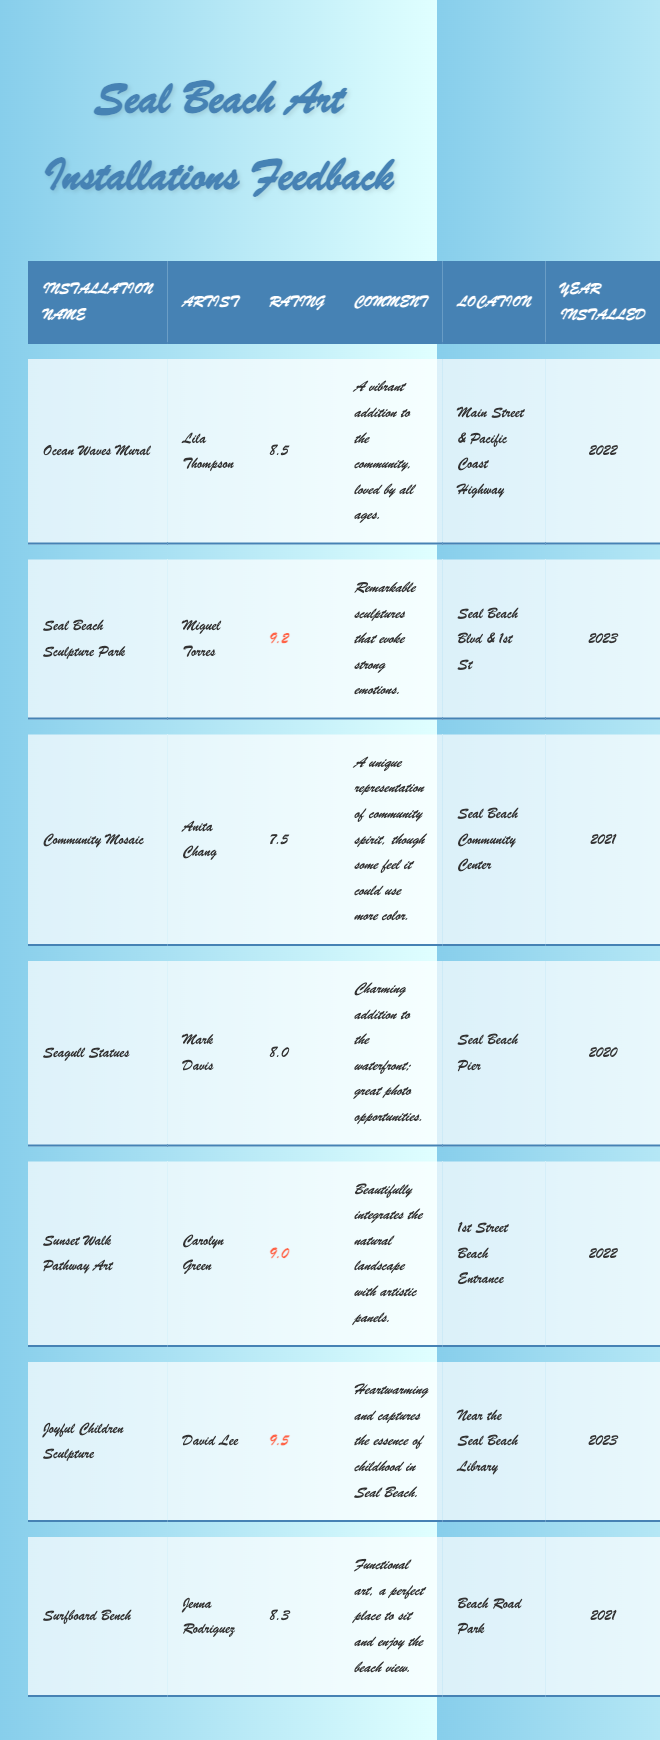What is the highest rating among the art installations? By inspecting the "Rating" column in the table, the highest value listed is 9.5, which corresponds to the "Joyful Children Sculpture" by David Lee.
Answer: 9.5 Which artist created the "Seal Beach Sculpture Park"? The table clearly states that "Seal Beach Sculpture Park" is created by Miguel Torres.
Answer: Miguel Torres What is the average rating of the installations installed in 2022? The ratings for the installations in 2022 are 8.5 (Ocean Waves Mural) and 9.0 (Sunset Walk Pathway Art). The average is calculated as (8.5 + 9.0) / 2 = 8.75.
Answer: 8.75 Is the "Community Mosaic" installation rated below 8? According to the table, the rating for "Community Mosaic" is 7.5, which is indeed below 8.
Answer: Yes How many installations have a rating of 9 or higher? By inspecting the ratings, the installations with ratings of 9 or higher are: Seal Beach Sculpture Park (9.2), Sunset Walk Pathway Art (9.0), and Joyful Children Sculpture (9.5), totaling 3 installations.
Answer: 3 Which installation has the comment mentioning a need for more color? The table notes that "Community Mosaic" has a comment that some feel it could use more color.
Answer: Community Mosaic What year was the installation with the lowest rating installed? The installation with the lowest rating is "Community Mosaic" at 7.5, and it was installed in 2021.
Answer: 2021 How does the rating of "Seagull Statues" compare to "Surfboard Bench"? "Seagull Statues" has a rating of 8.0, while "Surfboard Bench" has a rating of 8.3. Comparing these, Surfboard Bench has a higher rating.
Answer: Surfboard Bench is higher What is the difference between the highest and lowest ratings among the installations? The highest rating is 9.5 (Joyful Children Sculpture) and the lowest rating is 7.5 (Community Mosaic). The difference is 9.5 - 7.5 = 2.0.
Answer: 2.0 Who are the artists of all the installations installed in 2023? The installations in 2023 are "Seal Beach Sculpture Park" by Miguel Torres and "Joyful Children Sculpture" by David Lee. Both artists share the distinction of having their works rated highly this year.
Answer: Miguel Torres and David Lee 